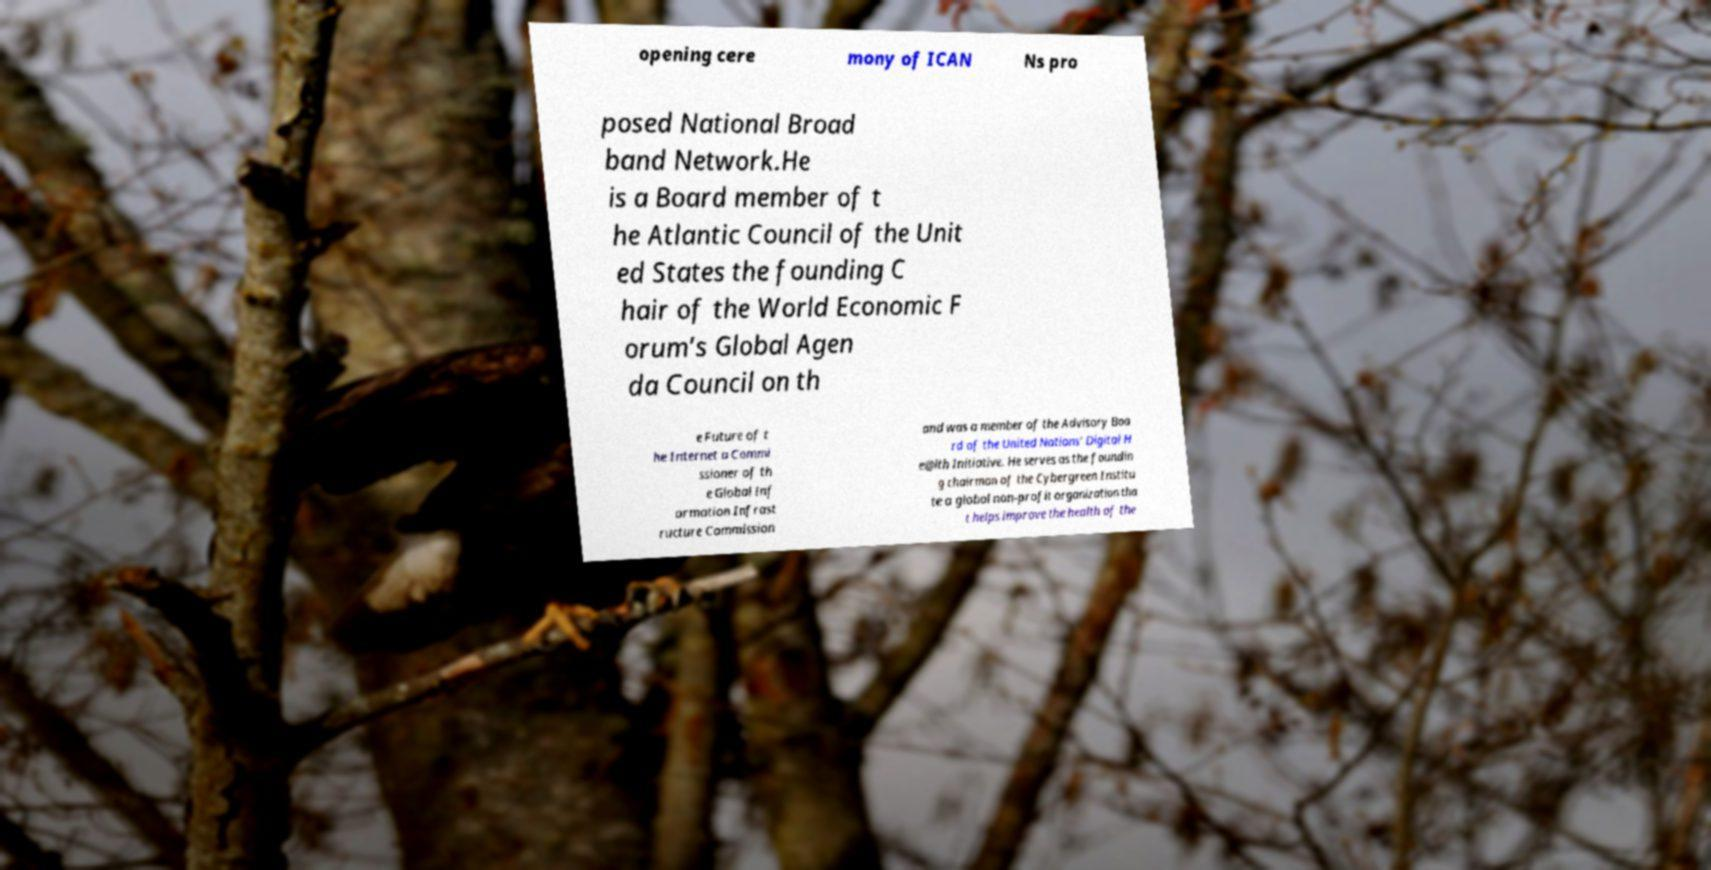There's text embedded in this image that I need extracted. Can you transcribe it verbatim? opening cere mony of ICAN Ns pro posed National Broad band Network.He is a Board member of t he Atlantic Council of the Unit ed States the founding C hair of the World Economic F orum’s Global Agen da Council on th e Future of t he Internet a Commi ssioner of th e Global Inf ormation Infrast ructure Commission and was a member of the Advisory Boa rd of the United Nations’ Digital H e@lth Initiative. He serves as the foundin g chairman of the Cybergreen Institu te a global non-profit organization tha t helps improve the health of the 